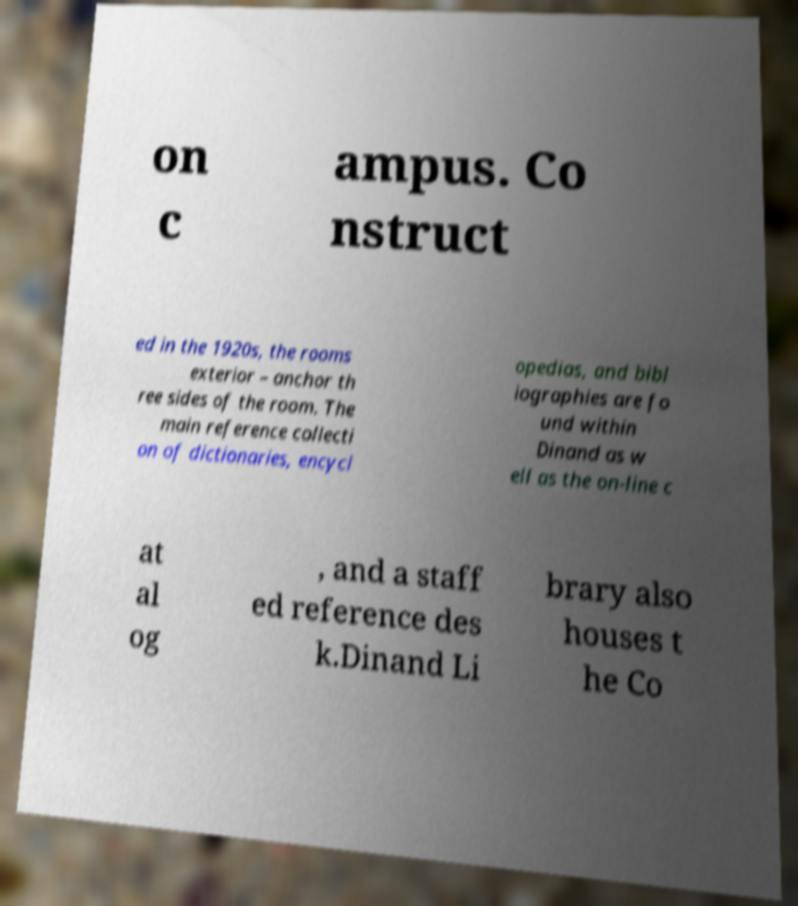Please read and relay the text visible in this image. What does it say? on c ampus. Co nstruct ed in the 1920s, the rooms exterior – anchor th ree sides of the room. The main reference collecti on of dictionaries, encycl opedias, and bibl iographies are fo und within Dinand as w ell as the on-line c at al og , and a staff ed reference des k.Dinand Li brary also houses t he Co 